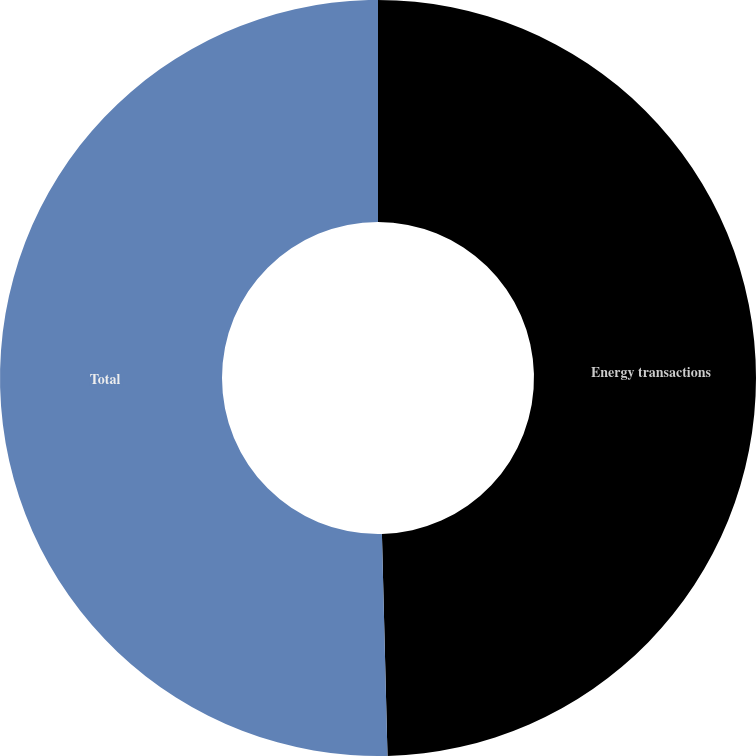Convert chart. <chart><loc_0><loc_0><loc_500><loc_500><pie_chart><fcel>Energy transactions<fcel>Total<nl><fcel>49.6%<fcel>50.4%<nl></chart> 